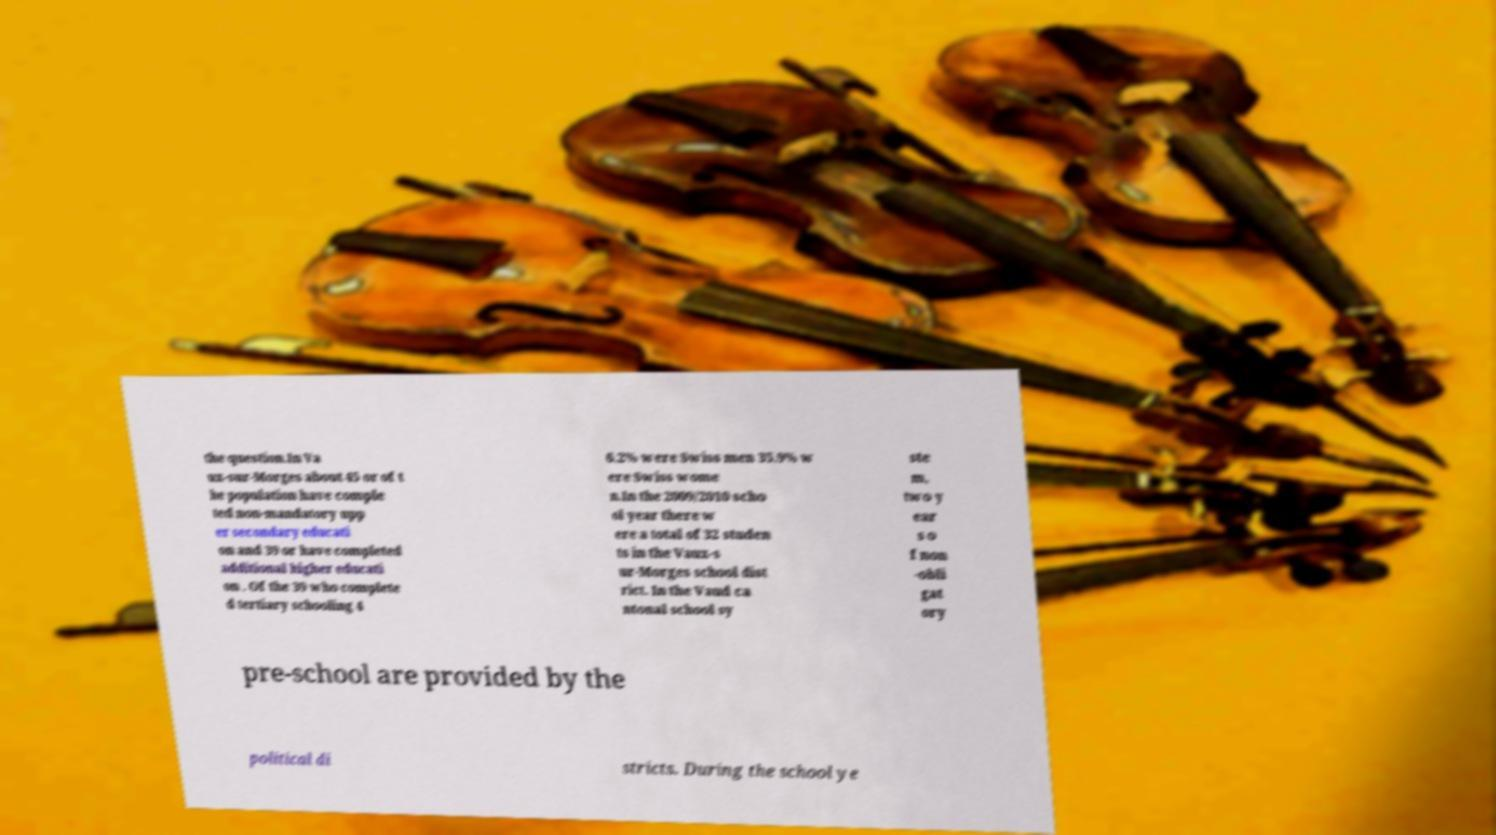For documentation purposes, I need the text within this image transcribed. Could you provide that? the question.In Va ux-sur-Morges about 45 or of t he population have comple ted non-mandatory upp er secondary educati on and 39 or have completed additional higher educati on . Of the 39 who complete d tertiary schooling 4 6.2% were Swiss men 35.9% w ere Swiss wome n.In the 2009/2010 scho ol year there w ere a total of 32 studen ts in the Vaux-s ur-Morges school dist rict. In the Vaud ca ntonal school sy ste m, two y ear s o f non -obli gat ory pre-school are provided by the political di stricts. During the school ye 